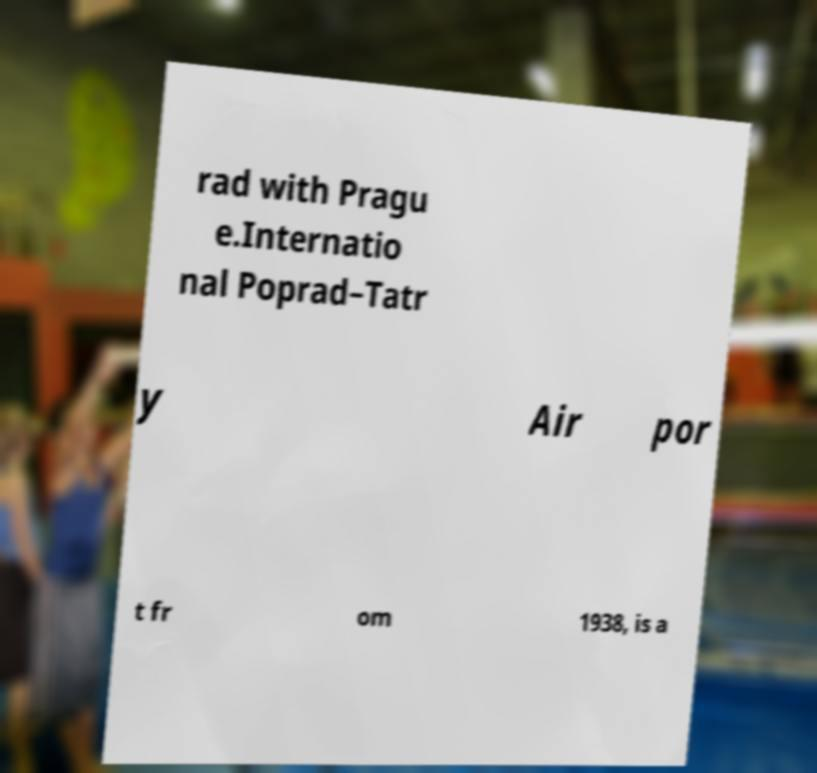There's text embedded in this image that I need extracted. Can you transcribe it verbatim? rad with Pragu e.Internatio nal Poprad–Tatr y Air por t fr om 1938, is a 